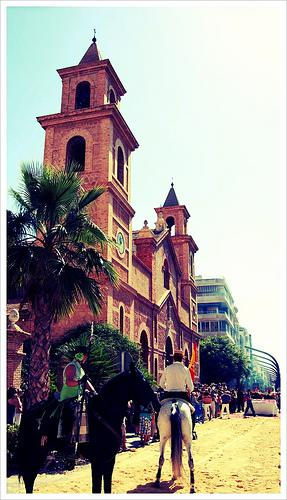Question: what type of animals are in this picture?
Choices:
A. Cows.
B. Chickens.
C. Dogs.
D. Horses.
Answer with the letter. Answer: D Question: how many clouds are in the sky?
Choices:
A. None.
B. One small cloud.
C. Two big clouds.
D. Three big clouds.
Answer with the letter. Answer: A Question: what kind of tree is closest to the camera?
Choices:
A. A fir tree.
B. A palm tree.
C. An oak tree.
D. An elm tree.
Answer with the letter. Answer: B Question: what material is the building made out of?
Choices:
A. Brick.
B. Plaster.
C. Adobe.
D. Wood.
Answer with the letter. Answer: A Question: what color hat is the man on the horse wearing?
Choices:
A. Black.
B. Orange.
C. Grey.
D. Red.
Answer with the letter. Answer: B 